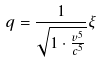Convert formula to latex. <formula><loc_0><loc_0><loc_500><loc_500>q = \frac { 1 } { \sqrt { 1 \cdot \frac { v ^ { 5 } } { c ^ { 5 } } } } \xi</formula> 